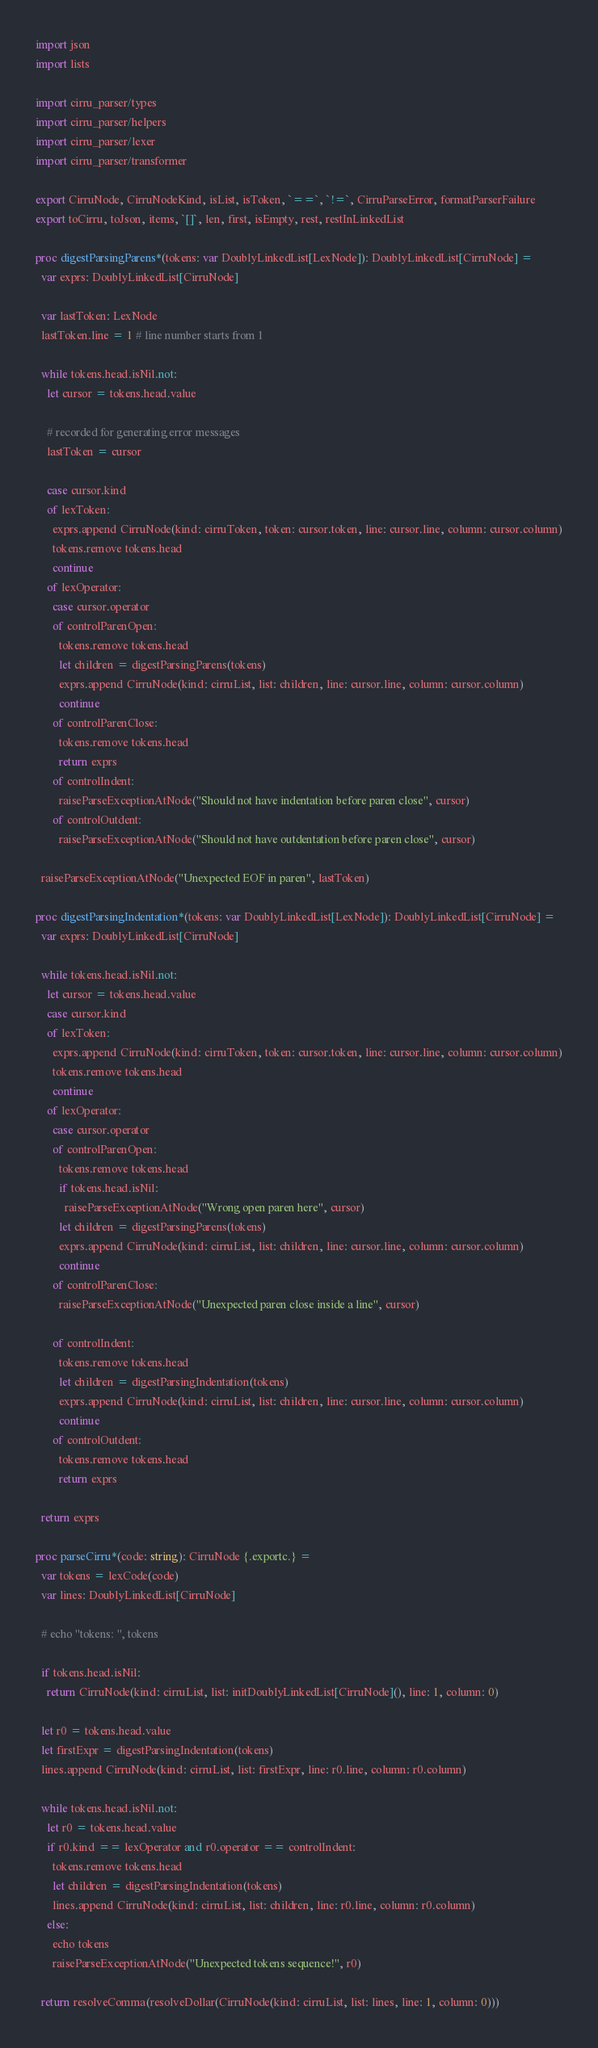Convert code to text. <code><loc_0><loc_0><loc_500><loc_500><_Nim_>import json
import lists

import cirru_parser/types
import cirru_parser/helpers
import cirru_parser/lexer
import cirru_parser/transformer

export CirruNode, CirruNodeKind, isList, isToken, `==`, `!=`, CirruParseError, formatParserFailure
export toCirru, toJson, items, `[]`, len, first, isEmpty, rest, restInLinkedList

proc digestParsingParens*(tokens: var DoublyLinkedList[LexNode]): DoublyLinkedList[CirruNode] =
  var exprs: DoublyLinkedList[CirruNode]

  var lastToken: LexNode
  lastToken.line = 1 # line number starts from 1

  while tokens.head.isNil.not:
    let cursor = tokens.head.value

    # recorded for generating error messages
    lastToken = cursor

    case cursor.kind
    of lexToken:
      exprs.append CirruNode(kind: cirruToken, token: cursor.token, line: cursor.line, column: cursor.column)
      tokens.remove tokens.head
      continue
    of lexOperator:
      case cursor.operator
      of controlParenOpen:
        tokens.remove tokens.head
        let children = digestParsingParens(tokens)
        exprs.append CirruNode(kind: cirruList, list: children, line: cursor.line, column: cursor.column)
        continue
      of controlParenClose:
        tokens.remove tokens.head
        return exprs
      of controlIndent:
        raiseParseExceptionAtNode("Should not have indentation before paren close", cursor)
      of controlOutdent:
        raiseParseExceptionAtNode("Should not have outdentation before paren close", cursor)

  raiseParseExceptionAtNode("Unexpected EOF in paren", lastToken)

proc digestParsingIndentation*(tokens: var DoublyLinkedList[LexNode]): DoublyLinkedList[CirruNode] =
  var exprs: DoublyLinkedList[CirruNode]

  while tokens.head.isNil.not:
    let cursor = tokens.head.value
    case cursor.kind
    of lexToken:
      exprs.append CirruNode(kind: cirruToken, token: cursor.token, line: cursor.line, column: cursor.column)
      tokens.remove tokens.head
      continue
    of lexOperator:
      case cursor.operator
      of controlParenOpen:
        tokens.remove tokens.head
        if tokens.head.isNil:
          raiseParseExceptionAtNode("Wrong open paren here", cursor)
        let children = digestParsingParens(tokens)
        exprs.append CirruNode(kind: cirruList, list: children, line: cursor.line, column: cursor.column)
        continue
      of controlParenClose:
        raiseParseExceptionAtNode("Unexpected paren close inside a line", cursor)

      of controlIndent:
        tokens.remove tokens.head
        let children = digestParsingIndentation(tokens)
        exprs.append CirruNode(kind: cirruList, list: children, line: cursor.line, column: cursor.column)
        continue
      of controlOutdent:
        tokens.remove tokens.head
        return exprs

  return exprs

proc parseCirru*(code: string): CirruNode {.exportc.} =
  var tokens = lexCode(code)
  var lines: DoublyLinkedList[CirruNode]

  # echo "tokens: ", tokens

  if tokens.head.isNil:
    return CirruNode(kind: cirruList, list: initDoublyLinkedList[CirruNode](), line: 1, column: 0)

  let r0 = tokens.head.value
  let firstExpr = digestParsingIndentation(tokens)
  lines.append CirruNode(kind: cirruList, list: firstExpr, line: r0.line, column: r0.column)

  while tokens.head.isNil.not:
    let r0 = tokens.head.value
    if r0.kind == lexOperator and r0.operator == controlIndent:
      tokens.remove tokens.head
      let children = digestParsingIndentation(tokens)
      lines.append CirruNode(kind: cirruList, list: children, line: r0.line, column: r0.column)
    else:
      echo tokens
      raiseParseExceptionAtNode("Unexpected tokens sequence!", r0)

  return resolveComma(resolveDollar(CirruNode(kind: cirruList, list: lines, line: 1, column: 0)))
</code> 